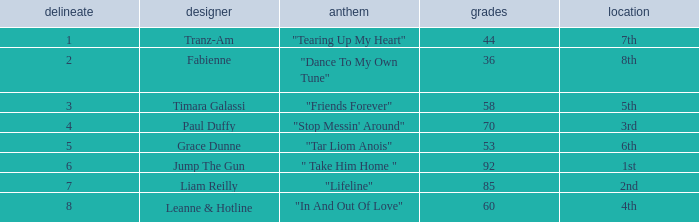What's the average amount of points for "in and out of love" with a draw over 8? None. 